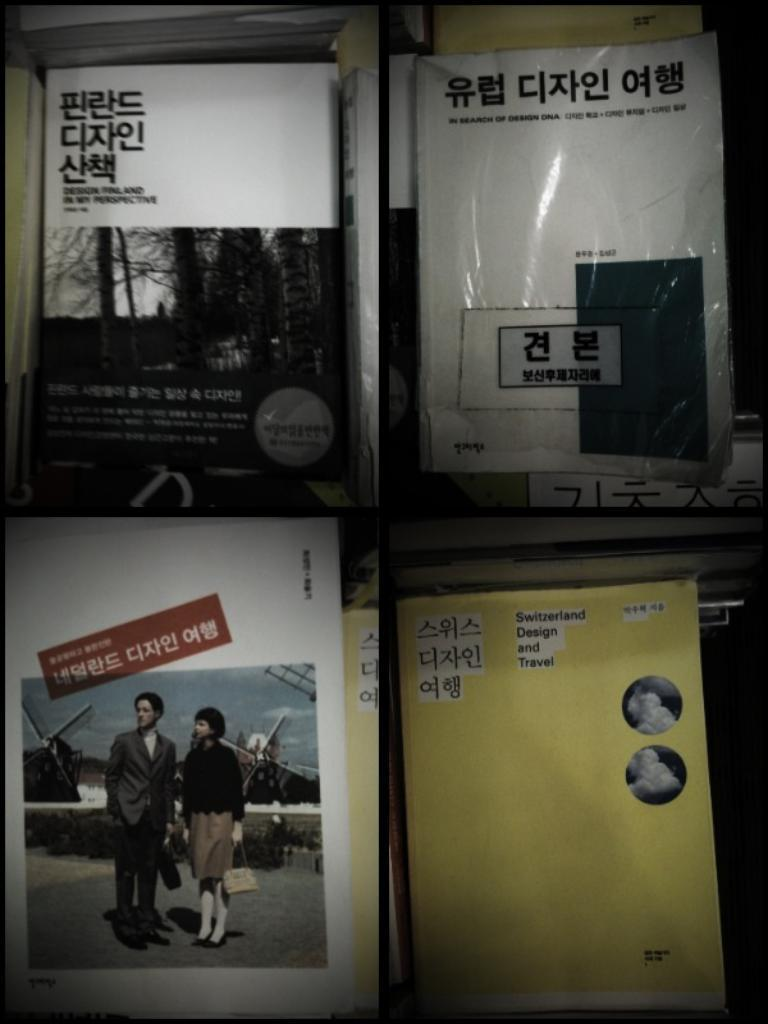What type of image is being described? The image is a collage. What can be found within the collage? There are different types of posters in the collage. What elements are included on the posters? The posters contain text and pictures. How many dolls can be seen in the collage? There are no dolls present in the collage; it consists of posters with text and pictures. 